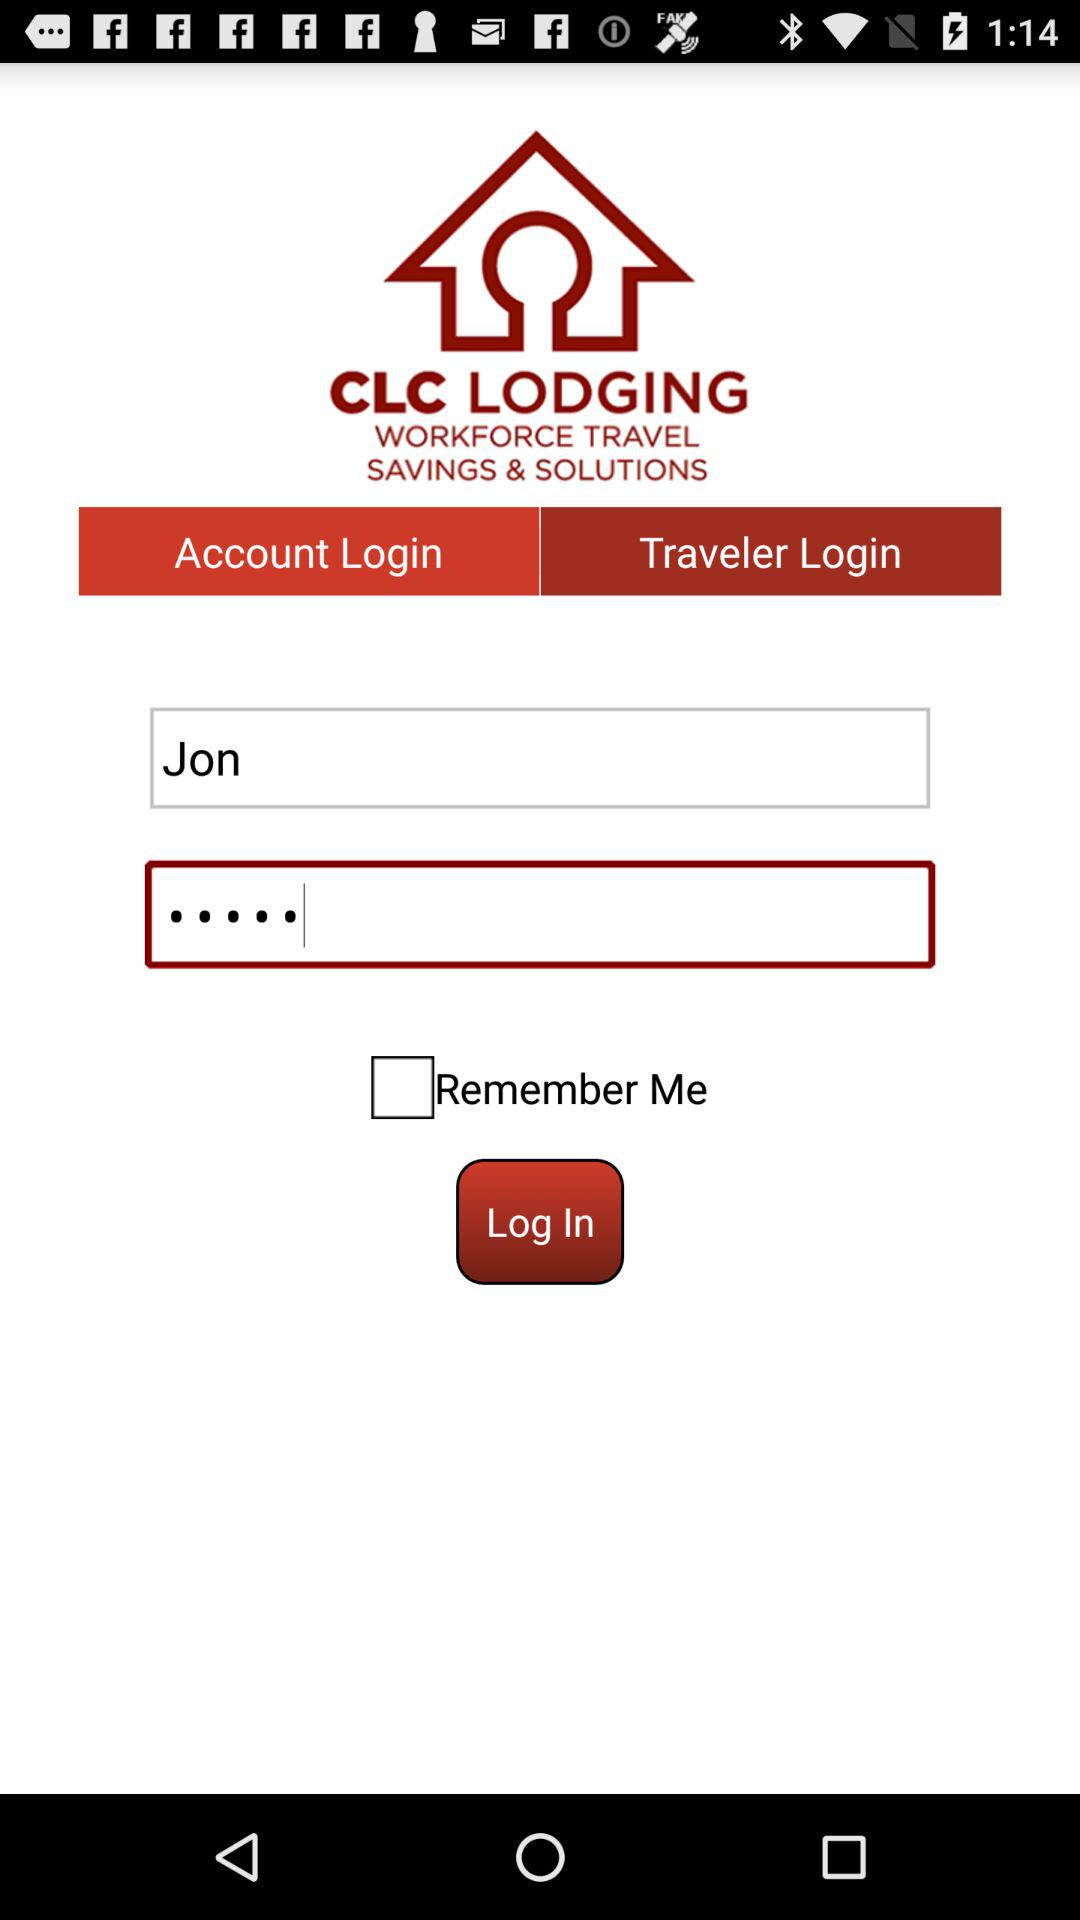How many text fields are there for the user to enter information?
Answer the question using a single word or phrase. 2 